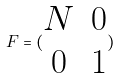Convert formula to latex. <formula><loc_0><loc_0><loc_500><loc_500>F = ( \begin{matrix} N & 0 \\ 0 & 1 \end{matrix} )</formula> 